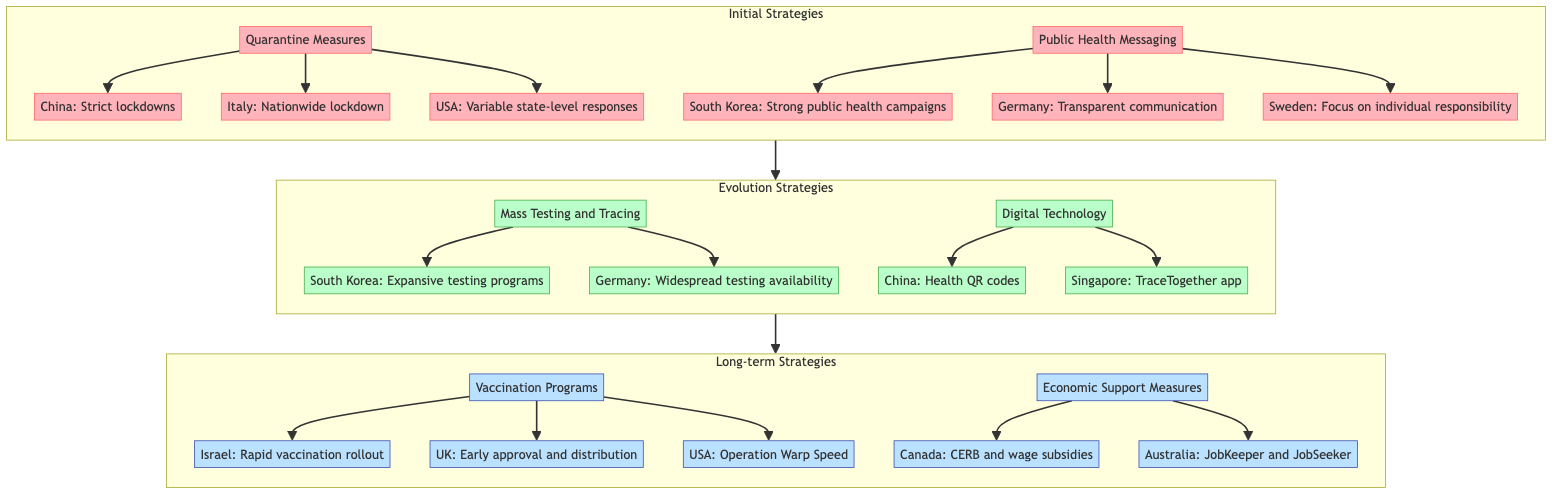What are the two categories of initial strategies in the diagram? The top node "Initial Strategies" branches into two categories: "Quarantine Measures" and "Public Health Messaging."
Answer: Quarantine Measures, Public Health Messaging Which country is associated with a nationwide lockdown in the initial strategies? In the "Quarantine Measures" category, the country that implemented a nationwide lockdown is Italy, as noted in the corresponding node.
Answer: Italy How many nodes are in the Evolution Strategies section? The "Evolution Strategies" section has two main nodes: "Mass Testing and Tracing" and "Digital Technology." Each of these has two sub-nodes, totaling four nodes in this section.
Answer: 4 Which country implemented health QR codes as part of their digital technology strategy? Under the "Digital Technology" category, the node related to health QR codes explicitly states that China implemented this measure.
Answer: China What is the primary focus of Sweden's public health messaging strategy? In the "Public Health Messaging" category, the node for Sweden indicates that their approach emphasizes focus on individual responsibility, which characterizes their strategy.
Answer: Individual responsibility How does South Korea's strategy evolve from initial to long-term? South Korea starts with strong public health campaigns in initial strategies, evolves to expansive testing programs in evolution strategies, and advances to robust vaccination programs in long-term strategies, indicating a progressive approach in epidemic control.
Answer: Progressive approach What economic support measure is associated with Canada? Within the "Economic Support Measures" section, the specific node indicates that Canada implemented the Canada Emergency Response Benefit and wage subsidies as key components of their strategy.
Answer: CERB and wage subsidies Which two long-term strategies are represented in the diagram? The "Long-term Strategies" node is divided into two categories: "Vaccination Programs" and "Economic Support Measures," which are both crucial for long-term epidemic control.
Answer: Vaccination Programs, Economic Support Measures How many countries implemented vaccination programs as part of long-term strategies? The "Vaccination Programs" node lists three specific countries—Israel, the UK, and the USA—highlighting their role in long-term strategies focused on vaccinations.
Answer: 3 